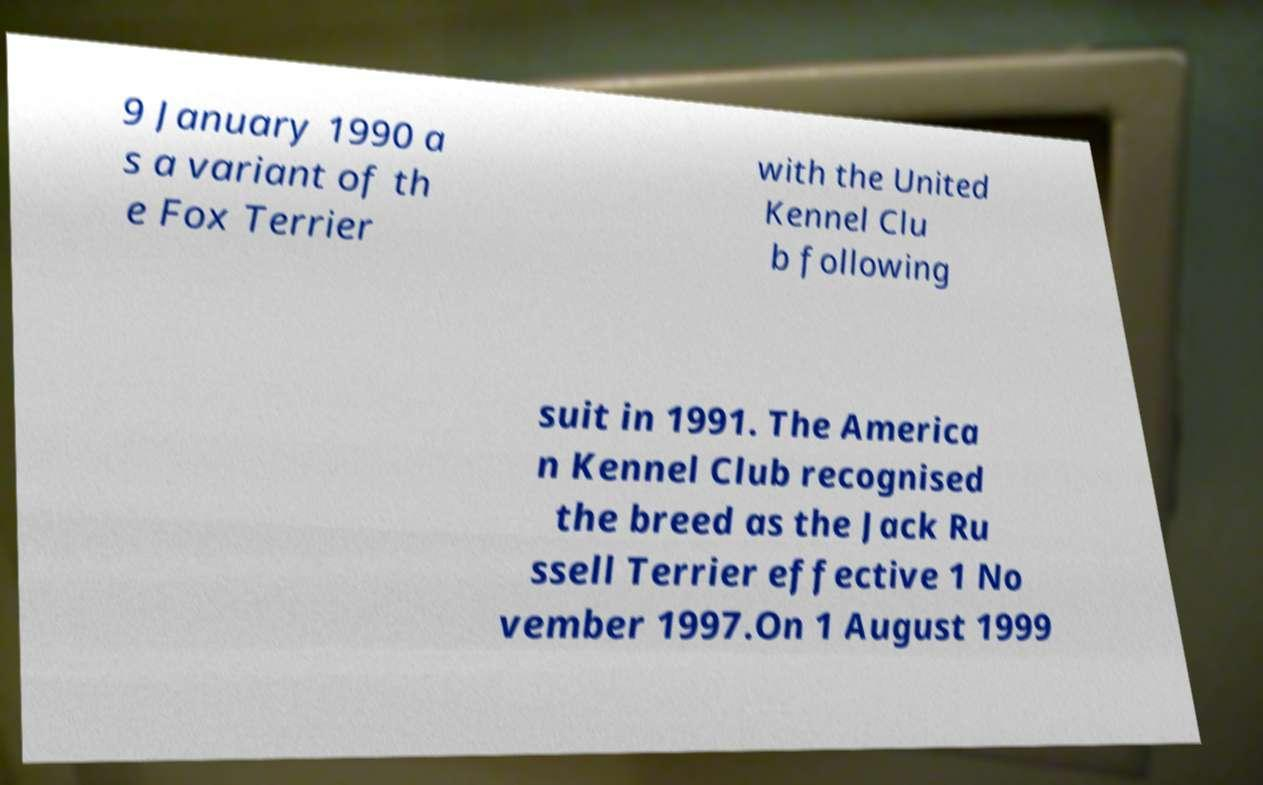Please identify and transcribe the text found in this image. 9 January 1990 a s a variant of th e Fox Terrier with the United Kennel Clu b following suit in 1991. The America n Kennel Club recognised the breed as the Jack Ru ssell Terrier effective 1 No vember 1997.On 1 August 1999 